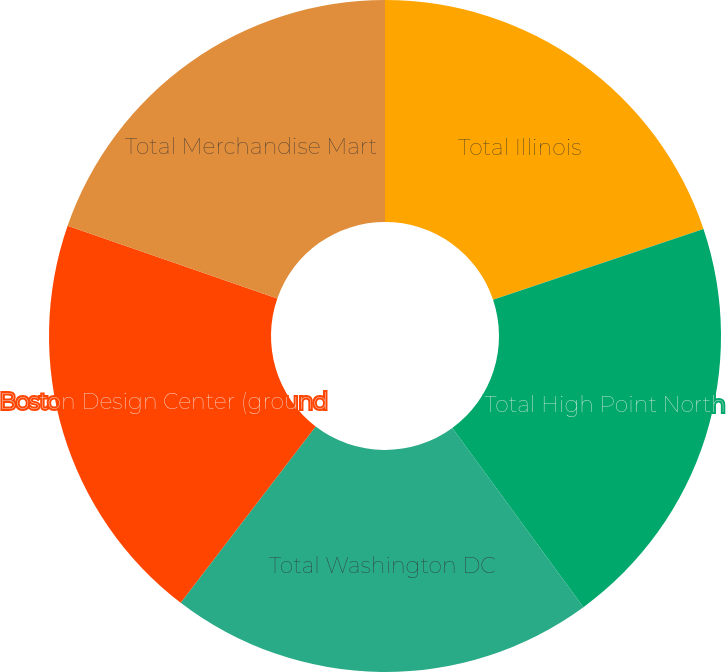Convert chart to OTSL. <chart><loc_0><loc_0><loc_500><loc_500><pie_chart><fcel>Total Illinois<fcel>Total High Point North<fcel>Total Washington DC<fcel>Boston Design Center (ground<fcel>Total Merchandise Mart<nl><fcel>19.84%<fcel>20.11%<fcel>20.46%<fcel>19.92%<fcel>19.68%<nl></chart> 